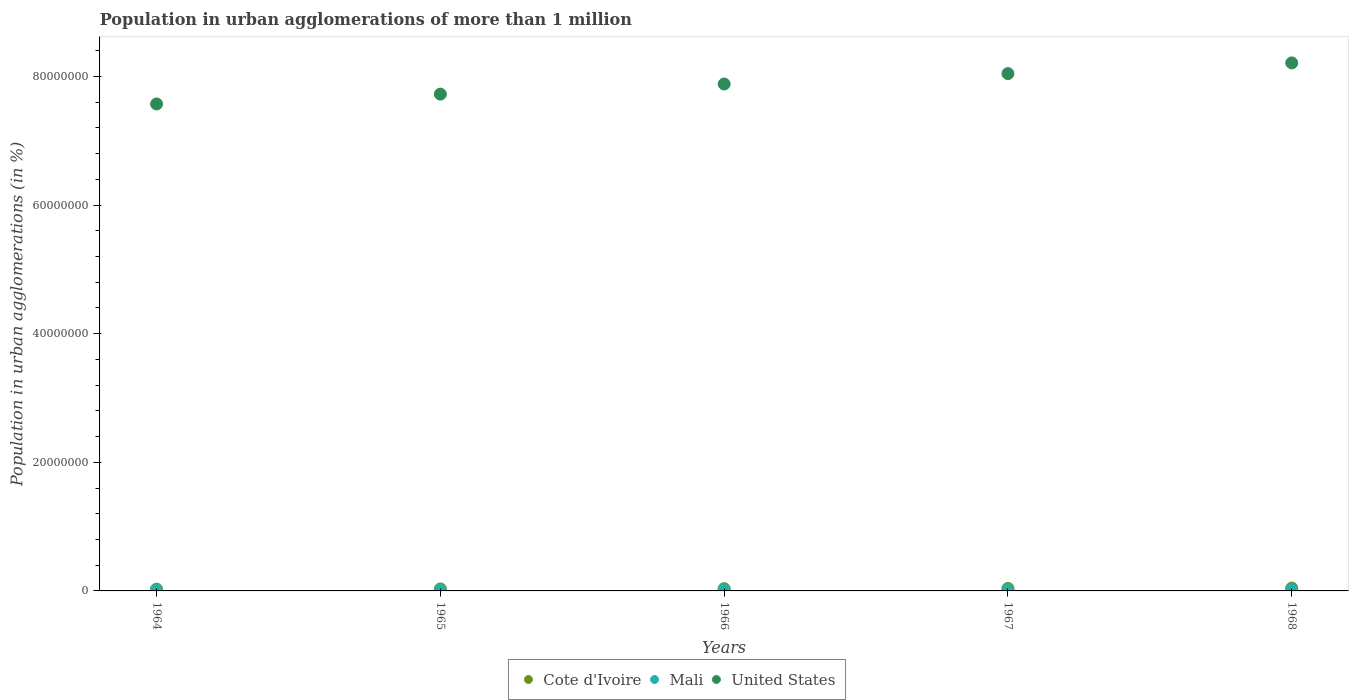How many different coloured dotlines are there?
Your answer should be very brief. 3. Is the number of dotlines equal to the number of legend labels?
Your response must be concise. Yes. What is the population in urban agglomerations in Mali in 1968?
Give a very brief answer. 1.82e+05. Across all years, what is the maximum population in urban agglomerations in United States?
Make the answer very short. 8.21e+07. Across all years, what is the minimum population in urban agglomerations in Cote d'Ivoire?
Your response must be concise. 2.77e+05. In which year was the population in urban agglomerations in Cote d'Ivoire maximum?
Offer a very short reply. 1968. In which year was the population in urban agglomerations in Cote d'Ivoire minimum?
Provide a succinct answer. 1964. What is the total population in urban agglomerations in Mali in the graph?
Ensure brevity in your answer.  8.31e+05. What is the difference between the population in urban agglomerations in Cote d'Ivoire in 1965 and that in 1966?
Your response must be concise. -3.75e+04. What is the difference between the population in urban agglomerations in Mali in 1966 and the population in urban agglomerations in United States in 1968?
Your answer should be very brief. -8.19e+07. What is the average population in urban agglomerations in Mali per year?
Offer a very short reply. 1.66e+05. In the year 1965, what is the difference between the population in urban agglomerations in Mali and population in urban agglomerations in United States?
Provide a succinct answer. -7.71e+07. What is the ratio of the population in urban agglomerations in Cote d'Ivoire in 1965 to that in 1967?
Offer a terse response. 0.8. Is the difference between the population in urban agglomerations in Mali in 1964 and 1965 greater than the difference between the population in urban agglomerations in United States in 1964 and 1965?
Give a very brief answer. Yes. What is the difference between the highest and the second highest population in urban agglomerations in Mali?
Make the answer very short. 8599. What is the difference between the highest and the lowest population in urban agglomerations in United States?
Your response must be concise. 6.38e+06. Is the sum of the population in urban agglomerations in Cote d'Ivoire in 1966 and 1967 greater than the maximum population in urban agglomerations in Mali across all years?
Your answer should be compact. Yes. Is the population in urban agglomerations in Mali strictly less than the population in urban agglomerations in Cote d'Ivoire over the years?
Your response must be concise. Yes. How many dotlines are there?
Give a very brief answer. 3. How many years are there in the graph?
Your answer should be very brief. 5. Does the graph contain any zero values?
Provide a short and direct response. No. Where does the legend appear in the graph?
Provide a short and direct response. Bottom center. How are the legend labels stacked?
Make the answer very short. Horizontal. What is the title of the graph?
Your answer should be compact. Population in urban agglomerations of more than 1 million. Does "Zambia" appear as one of the legend labels in the graph?
Give a very brief answer. No. What is the label or title of the Y-axis?
Your answer should be compact. Population in urban agglomerations (in %). What is the Population in urban agglomerations (in %) in Cote d'Ivoire in 1964?
Provide a succinct answer. 2.77e+05. What is the Population in urban agglomerations (in %) in Mali in 1964?
Provide a succinct answer. 1.52e+05. What is the Population in urban agglomerations (in %) of United States in 1964?
Keep it short and to the point. 7.57e+07. What is the Population in urban agglomerations (in %) in Cote d'Ivoire in 1965?
Keep it short and to the point. 3.10e+05. What is the Population in urban agglomerations (in %) of Mali in 1965?
Provide a succinct answer. 1.58e+05. What is the Population in urban agglomerations (in %) of United States in 1965?
Offer a very short reply. 7.73e+07. What is the Population in urban agglomerations (in %) in Cote d'Ivoire in 1966?
Provide a short and direct response. 3.47e+05. What is the Population in urban agglomerations (in %) in Mali in 1966?
Keep it short and to the point. 1.65e+05. What is the Population in urban agglomerations (in %) of United States in 1966?
Keep it short and to the point. 7.88e+07. What is the Population in urban agglomerations (in %) in Cote d'Ivoire in 1967?
Offer a very short reply. 3.89e+05. What is the Population in urban agglomerations (in %) of Mali in 1967?
Your answer should be very brief. 1.73e+05. What is the Population in urban agglomerations (in %) of United States in 1967?
Your response must be concise. 8.04e+07. What is the Population in urban agglomerations (in %) in Cote d'Ivoire in 1968?
Offer a very short reply. 4.36e+05. What is the Population in urban agglomerations (in %) of Mali in 1968?
Your answer should be very brief. 1.82e+05. What is the Population in urban agglomerations (in %) in United States in 1968?
Your answer should be very brief. 8.21e+07. Across all years, what is the maximum Population in urban agglomerations (in %) in Cote d'Ivoire?
Ensure brevity in your answer.  4.36e+05. Across all years, what is the maximum Population in urban agglomerations (in %) in Mali?
Your answer should be very brief. 1.82e+05. Across all years, what is the maximum Population in urban agglomerations (in %) of United States?
Offer a terse response. 8.21e+07. Across all years, what is the minimum Population in urban agglomerations (in %) of Cote d'Ivoire?
Ensure brevity in your answer.  2.77e+05. Across all years, what is the minimum Population in urban agglomerations (in %) of Mali?
Your answer should be very brief. 1.52e+05. Across all years, what is the minimum Population in urban agglomerations (in %) in United States?
Provide a succinct answer. 7.57e+07. What is the total Population in urban agglomerations (in %) of Cote d'Ivoire in the graph?
Give a very brief answer. 1.76e+06. What is the total Population in urban agglomerations (in %) of Mali in the graph?
Your answer should be compact. 8.31e+05. What is the total Population in urban agglomerations (in %) of United States in the graph?
Your answer should be compact. 3.94e+08. What is the difference between the Population in urban agglomerations (in %) of Cote d'Ivoire in 1964 and that in 1965?
Your answer should be very brief. -3.34e+04. What is the difference between the Population in urban agglomerations (in %) of Mali in 1964 and that in 1965?
Offer a terse response. -6172. What is the difference between the Population in urban agglomerations (in %) in United States in 1964 and that in 1965?
Keep it short and to the point. -1.53e+06. What is the difference between the Population in urban agglomerations (in %) in Cote d'Ivoire in 1964 and that in 1966?
Make the answer very short. -7.08e+04. What is the difference between the Population in urban agglomerations (in %) in Mali in 1964 and that in 1966?
Your response must be concise. -1.33e+04. What is the difference between the Population in urban agglomerations (in %) of United States in 1964 and that in 1966?
Offer a terse response. -3.10e+06. What is the difference between the Population in urban agglomerations (in %) in Cote d'Ivoire in 1964 and that in 1967?
Offer a terse response. -1.13e+05. What is the difference between the Population in urban agglomerations (in %) of Mali in 1964 and that in 1967?
Your answer should be very brief. -2.15e+04. What is the difference between the Population in urban agglomerations (in %) of United States in 1964 and that in 1967?
Offer a terse response. -4.72e+06. What is the difference between the Population in urban agglomerations (in %) in Cote d'Ivoire in 1964 and that in 1968?
Make the answer very short. -1.60e+05. What is the difference between the Population in urban agglomerations (in %) in Mali in 1964 and that in 1968?
Ensure brevity in your answer.  -3.01e+04. What is the difference between the Population in urban agglomerations (in %) of United States in 1964 and that in 1968?
Your answer should be very brief. -6.38e+06. What is the difference between the Population in urban agglomerations (in %) in Cote d'Ivoire in 1965 and that in 1966?
Provide a short and direct response. -3.75e+04. What is the difference between the Population in urban agglomerations (in %) in Mali in 1965 and that in 1966?
Give a very brief answer. -7126. What is the difference between the Population in urban agglomerations (in %) in United States in 1965 and that in 1966?
Make the answer very short. -1.57e+06. What is the difference between the Population in urban agglomerations (in %) of Cote d'Ivoire in 1965 and that in 1967?
Ensure brevity in your answer.  -7.94e+04. What is the difference between the Population in urban agglomerations (in %) of Mali in 1965 and that in 1967?
Offer a terse response. -1.53e+04. What is the difference between the Population in urban agglomerations (in %) of United States in 1965 and that in 1967?
Your answer should be compact. -3.19e+06. What is the difference between the Population in urban agglomerations (in %) of Cote d'Ivoire in 1965 and that in 1968?
Provide a succinct answer. -1.27e+05. What is the difference between the Population in urban agglomerations (in %) of Mali in 1965 and that in 1968?
Your answer should be very brief. -2.39e+04. What is the difference between the Population in urban agglomerations (in %) in United States in 1965 and that in 1968?
Give a very brief answer. -4.85e+06. What is the difference between the Population in urban agglomerations (in %) of Cote d'Ivoire in 1966 and that in 1967?
Provide a short and direct response. -4.20e+04. What is the difference between the Population in urban agglomerations (in %) of Mali in 1966 and that in 1967?
Offer a very short reply. -8183. What is the difference between the Population in urban agglomerations (in %) of United States in 1966 and that in 1967?
Your answer should be compact. -1.62e+06. What is the difference between the Population in urban agglomerations (in %) in Cote d'Ivoire in 1966 and that in 1968?
Ensure brevity in your answer.  -8.91e+04. What is the difference between the Population in urban agglomerations (in %) in Mali in 1966 and that in 1968?
Offer a terse response. -1.68e+04. What is the difference between the Population in urban agglomerations (in %) in United States in 1966 and that in 1968?
Make the answer very short. -3.28e+06. What is the difference between the Population in urban agglomerations (in %) of Cote d'Ivoire in 1967 and that in 1968?
Keep it short and to the point. -4.71e+04. What is the difference between the Population in urban agglomerations (in %) in Mali in 1967 and that in 1968?
Give a very brief answer. -8599. What is the difference between the Population in urban agglomerations (in %) in United States in 1967 and that in 1968?
Give a very brief answer. -1.66e+06. What is the difference between the Population in urban agglomerations (in %) of Cote d'Ivoire in 1964 and the Population in urban agglomerations (in %) of Mali in 1965?
Give a very brief answer. 1.18e+05. What is the difference between the Population in urban agglomerations (in %) of Cote d'Ivoire in 1964 and the Population in urban agglomerations (in %) of United States in 1965?
Ensure brevity in your answer.  -7.70e+07. What is the difference between the Population in urban agglomerations (in %) in Mali in 1964 and the Population in urban agglomerations (in %) in United States in 1965?
Provide a succinct answer. -7.71e+07. What is the difference between the Population in urban agglomerations (in %) in Cote d'Ivoire in 1964 and the Population in urban agglomerations (in %) in Mali in 1966?
Ensure brevity in your answer.  1.11e+05. What is the difference between the Population in urban agglomerations (in %) of Cote d'Ivoire in 1964 and the Population in urban agglomerations (in %) of United States in 1966?
Make the answer very short. -7.86e+07. What is the difference between the Population in urban agglomerations (in %) in Mali in 1964 and the Population in urban agglomerations (in %) in United States in 1966?
Offer a terse response. -7.87e+07. What is the difference between the Population in urban agglomerations (in %) of Cote d'Ivoire in 1964 and the Population in urban agglomerations (in %) of Mali in 1967?
Offer a very short reply. 1.03e+05. What is the difference between the Population in urban agglomerations (in %) of Cote d'Ivoire in 1964 and the Population in urban agglomerations (in %) of United States in 1967?
Keep it short and to the point. -8.02e+07. What is the difference between the Population in urban agglomerations (in %) in Mali in 1964 and the Population in urban agglomerations (in %) in United States in 1967?
Offer a terse response. -8.03e+07. What is the difference between the Population in urban agglomerations (in %) of Cote d'Ivoire in 1964 and the Population in urban agglomerations (in %) of Mali in 1968?
Provide a succinct answer. 9.46e+04. What is the difference between the Population in urban agglomerations (in %) in Cote d'Ivoire in 1964 and the Population in urban agglomerations (in %) in United States in 1968?
Give a very brief answer. -8.18e+07. What is the difference between the Population in urban agglomerations (in %) in Mali in 1964 and the Population in urban agglomerations (in %) in United States in 1968?
Provide a succinct answer. -8.20e+07. What is the difference between the Population in urban agglomerations (in %) in Cote d'Ivoire in 1965 and the Population in urban agglomerations (in %) in Mali in 1966?
Make the answer very short. 1.45e+05. What is the difference between the Population in urban agglomerations (in %) of Cote d'Ivoire in 1965 and the Population in urban agglomerations (in %) of United States in 1966?
Provide a succinct answer. -7.85e+07. What is the difference between the Population in urban agglomerations (in %) of Mali in 1965 and the Population in urban agglomerations (in %) of United States in 1966?
Provide a short and direct response. -7.87e+07. What is the difference between the Population in urban agglomerations (in %) in Cote d'Ivoire in 1965 and the Population in urban agglomerations (in %) in Mali in 1967?
Keep it short and to the point. 1.37e+05. What is the difference between the Population in urban agglomerations (in %) in Cote d'Ivoire in 1965 and the Population in urban agglomerations (in %) in United States in 1967?
Your answer should be very brief. -8.01e+07. What is the difference between the Population in urban agglomerations (in %) of Mali in 1965 and the Population in urban agglomerations (in %) of United States in 1967?
Provide a short and direct response. -8.03e+07. What is the difference between the Population in urban agglomerations (in %) of Cote d'Ivoire in 1965 and the Population in urban agglomerations (in %) of Mali in 1968?
Offer a terse response. 1.28e+05. What is the difference between the Population in urban agglomerations (in %) of Cote d'Ivoire in 1965 and the Population in urban agglomerations (in %) of United States in 1968?
Make the answer very short. -8.18e+07. What is the difference between the Population in urban agglomerations (in %) of Mali in 1965 and the Population in urban agglomerations (in %) of United States in 1968?
Offer a very short reply. -8.19e+07. What is the difference between the Population in urban agglomerations (in %) in Cote d'Ivoire in 1966 and the Population in urban agglomerations (in %) in Mali in 1967?
Keep it short and to the point. 1.74e+05. What is the difference between the Population in urban agglomerations (in %) in Cote d'Ivoire in 1966 and the Population in urban agglomerations (in %) in United States in 1967?
Your answer should be very brief. -8.01e+07. What is the difference between the Population in urban agglomerations (in %) in Mali in 1966 and the Population in urban agglomerations (in %) in United States in 1967?
Keep it short and to the point. -8.03e+07. What is the difference between the Population in urban agglomerations (in %) in Cote d'Ivoire in 1966 and the Population in urban agglomerations (in %) in Mali in 1968?
Provide a succinct answer. 1.65e+05. What is the difference between the Population in urban agglomerations (in %) of Cote d'Ivoire in 1966 and the Population in urban agglomerations (in %) of United States in 1968?
Provide a succinct answer. -8.18e+07. What is the difference between the Population in urban agglomerations (in %) of Mali in 1966 and the Population in urban agglomerations (in %) of United States in 1968?
Your answer should be compact. -8.19e+07. What is the difference between the Population in urban agglomerations (in %) in Cote d'Ivoire in 1967 and the Population in urban agglomerations (in %) in Mali in 1968?
Ensure brevity in your answer.  2.07e+05. What is the difference between the Population in urban agglomerations (in %) of Cote d'Ivoire in 1967 and the Population in urban agglomerations (in %) of United States in 1968?
Ensure brevity in your answer.  -8.17e+07. What is the difference between the Population in urban agglomerations (in %) of Mali in 1967 and the Population in urban agglomerations (in %) of United States in 1968?
Ensure brevity in your answer.  -8.19e+07. What is the average Population in urban agglomerations (in %) in Cote d'Ivoire per year?
Provide a short and direct response. 3.52e+05. What is the average Population in urban agglomerations (in %) in Mali per year?
Your answer should be very brief. 1.66e+05. What is the average Population in urban agglomerations (in %) in United States per year?
Make the answer very short. 7.89e+07. In the year 1964, what is the difference between the Population in urban agglomerations (in %) in Cote d'Ivoire and Population in urban agglomerations (in %) in Mali?
Your answer should be very brief. 1.25e+05. In the year 1964, what is the difference between the Population in urban agglomerations (in %) of Cote d'Ivoire and Population in urban agglomerations (in %) of United States?
Keep it short and to the point. -7.54e+07. In the year 1964, what is the difference between the Population in urban agglomerations (in %) in Mali and Population in urban agglomerations (in %) in United States?
Give a very brief answer. -7.56e+07. In the year 1965, what is the difference between the Population in urban agglomerations (in %) in Cote d'Ivoire and Population in urban agglomerations (in %) in Mali?
Give a very brief answer. 1.52e+05. In the year 1965, what is the difference between the Population in urban agglomerations (in %) of Cote d'Ivoire and Population in urban agglomerations (in %) of United States?
Provide a short and direct response. -7.69e+07. In the year 1965, what is the difference between the Population in urban agglomerations (in %) of Mali and Population in urban agglomerations (in %) of United States?
Give a very brief answer. -7.71e+07. In the year 1966, what is the difference between the Population in urban agglomerations (in %) in Cote d'Ivoire and Population in urban agglomerations (in %) in Mali?
Your response must be concise. 1.82e+05. In the year 1966, what is the difference between the Population in urban agglomerations (in %) in Cote d'Ivoire and Population in urban agglomerations (in %) in United States?
Keep it short and to the point. -7.85e+07. In the year 1966, what is the difference between the Population in urban agglomerations (in %) in Mali and Population in urban agglomerations (in %) in United States?
Make the answer very short. -7.87e+07. In the year 1967, what is the difference between the Population in urban agglomerations (in %) of Cote d'Ivoire and Population in urban agglomerations (in %) of Mali?
Keep it short and to the point. 2.16e+05. In the year 1967, what is the difference between the Population in urban agglomerations (in %) in Cote d'Ivoire and Population in urban agglomerations (in %) in United States?
Your answer should be compact. -8.01e+07. In the year 1967, what is the difference between the Population in urban agglomerations (in %) in Mali and Population in urban agglomerations (in %) in United States?
Give a very brief answer. -8.03e+07. In the year 1968, what is the difference between the Population in urban agglomerations (in %) of Cote d'Ivoire and Population in urban agglomerations (in %) of Mali?
Ensure brevity in your answer.  2.54e+05. In the year 1968, what is the difference between the Population in urban agglomerations (in %) in Cote d'Ivoire and Population in urban agglomerations (in %) in United States?
Offer a very short reply. -8.17e+07. In the year 1968, what is the difference between the Population in urban agglomerations (in %) in Mali and Population in urban agglomerations (in %) in United States?
Give a very brief answer. -8.19e+07. What is the ratio of the Population in urban agglomerations (in %) of Cote d'Ivoire in 1964 to that in 1965?
Your answer should be compact. 0.89. What is the ratio of the Population in urban agglomerations (in %) in United States in 1964 to that in 1965?
Keep it short and to the point. 0.98. What is the ratio of the Population in urban agglomerations (in %) in Cote d'Ivoire in 1964 to that in 1966?
Keep it short and to the point. 0.8. What is the ratio of the Population in urban agglomerations (in %) in Mali in 1964 to that in 1966?
Offer a terse response. 0.92. What is the ratio of the Population in urban agglomerations (in %) of United States in 1964 to that in 1966?
Keep it short and to the point. 0.96. What is the ratio of the Population in urban agglomerations (in %) in Cote d'Ivoire in 1964 to that in 1967?
Provide a short and direct response. 0.71. What is the ratio of the Population in urban agglomerations (in %) in Mali in 1964 to that in 1967?
Give a very brief answer. 0.88. What is the ratio of the Population in urban agglomerations (in %) of United States in 1964 to that in 1967?
Your answer should be compact. 0.94. What is the ratio of the Population in urban agglomerations (in %) in Cote d'Ivoire in 1964 to that in 1968?
Offer a terse response. 0.63. What is the ratio of the Population in urban agglomerations (in %) in Mali in 1964 to that in 1968?
Ensure brevity in your answer.  0.83. What is the ratio of the Population in urban agglomerations (in %) of United States in 1964 to that in 1968?
Your answer should be compact. 0.92. What is the ratio of the Population in urban agglomerations (in %) in Cote d'Ivoire in 1965 to that in 1966?
Offer a very short reply. 0.89. What is the ratio of the Population in urban agglomerations (in %) in Mali in 1965 to that in 1966?
Keep it short and to the point. 0.96. What is the ratio of the Population in urban agglomerations (in %) in Cote d'Ivoire in 1965 to that in 1967?
Provide a succinct answer. 0.8. What is the ratio of the Population in urban agglomerations (in %) of Mali in 1965 to that in 1967?
Offer a very short reply. 0.91. What is the ratio of the Population in urban agglomerations (in %) of United States in 1965 to that in 1967?
Give a very brief answer. 0.96. What is the ratio of the Population in urban agglomerations (in %) in Cote d'Ivoire in 1965 to that in 1968?
Offer a terse response. 0.71. What is the ratio of the Population in urban agglomerations (in %) in Mali in 1965 to that in 1968?
Offer a very short reply. 0.87. What is the ratio of the Population in urban agglomerations (in %) of United States in 1965 to that in 1968?
Offer a terse response. 0.94. What is the ratio of the Population in urban agglomerations (in %) in Cote d'Ivoire in 1966 to that in 1967?
Offer a very short reply. 0.89. What is the ratio of the Population in urban agglomerations (in %) in Mali in 1966 to that in 1967?
Your answer should be compact. 0.95. What is the ratio of the Population in urban agglomerations (in %) in United States in 1966 to that in 1967?
Provide a short and direct response. 0.98. What is the ratio of the Population in urban agglomerations (in %) in Cote d'Ivoire in 1966 to that in 1968?
Ensure brevity in your answer.  0.8. What is the ratio of the Population in urban agglomerations (in %) of Mali in 1966 to that in 1968?
Your answer should be very brief. 0.91. What is the ratio of the Population in urban agglomerations (in %) in United States in 1966 to that in 1968?
Make the answer very short. 0.96. What is the ratio of the Population in urban agglomerations (in %) of Cote d'Ivoire in 1967 to that in 1968?
Offer a terse response. 0.89. What is the ratio of the Population in urban agglomerations (in %) of Mali in 1967 to that in 1968?
Your answer should be compact. 0.95. What is the ratio of the Population in urban agglomerations (in %) in United States in 1967 to that in 1968?
Keep it short and to the point. 0.98. What is the difference between the highest and the second highest Population in urban agglomerations (in %) of Cote d'Ivoire?
Keep it short and to the point. 4.71e+04. What is the difference between the highest and the second highest Population in urban agglomerations (in %) of Mali?
Offer a terse response. 8599. What is the difference between the highest and the second highest Population in urban agglomerations (in %) of United States?
Your response must be concise. 1.66e+06. What is the difference between the highest and the lowest Population in urban agglomerations (in %) in Cote d'Ivoire?
Give a very brief answer. 1.60e+05. What is the difference between the highest and the lowest Population in urban agglomerations (in %) in Mali?
Your response must be concise. 3.01e+04. What is the difference between the highest and the lowest Population in urban agglomerations (in %) of United States?
Your response must be concise. 6.38e+06. 